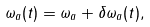Convert formula to latex. <formula><loc_0><loc_0><loc_500><loc_500>\omega _ { a } ( t ) = \omega _ { a } + \delta \omega _ { a } ( t ) ,</formula> 